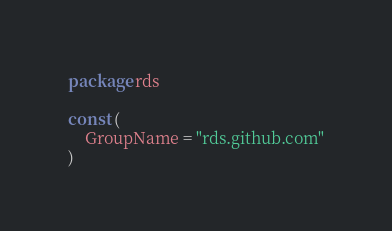<code> <loc_0><loc_0><loc_500><loc_500><_Go_>package rds

const (
	GroupName = "rds.github.com"
)
</code> 